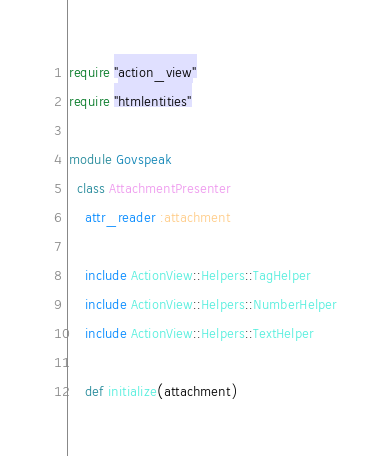<code> <loc_0><loc_0><loc_500><loc_500><_Ruby_>require "action_view"
require "htmlentities"

module Govspeak
  class AttachmentPresenter
    attr_reader :attachment

    include ActionView::Helpers::TagHelper
    include ActionView::Helpers::NumberHelper
    include ActionView::Helpers::TextHelper

    def initialize(attachment)</code> 